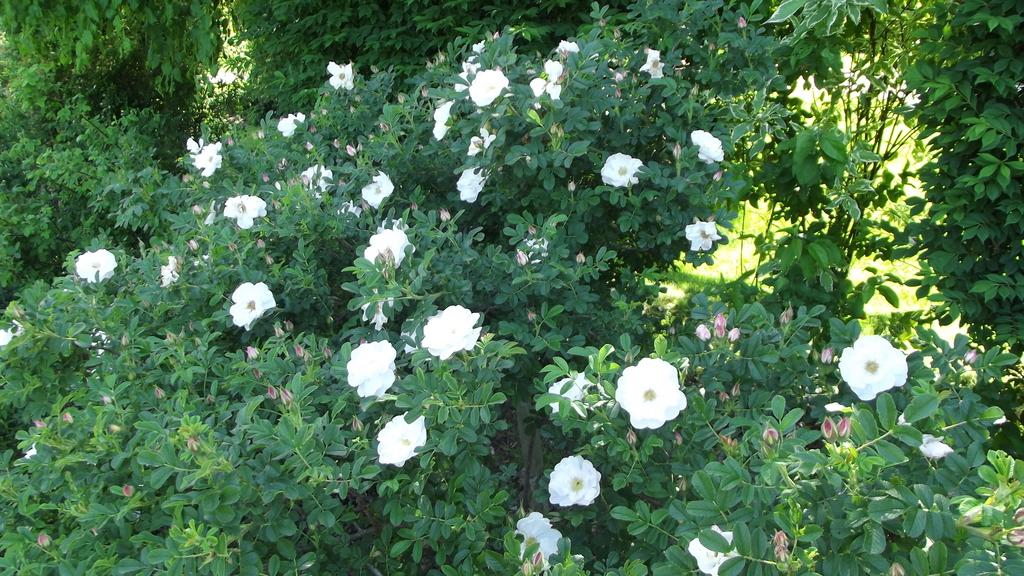What type of flowers are in the foreground of the image? There are white flowers in the foreground of the image. What are the flowers growing on? The flowers are on plants. What can be seen in the background of the image? There is greenery in the background of the image. What type of ring can be seen on the skirt in the image? There is no ring or skirt present in the image; it features white flowers on plants with greenery in the background. 